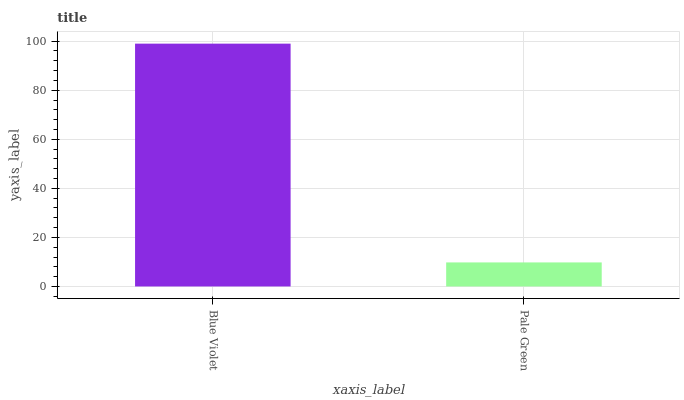Is Pale Green the minimum?
Answer yes or no. Yes. Is Blue Violet the maximum?
Answer yes or no. Yes. Is Pale Green the maximum?
Answer yes or no. No. Is Blue Violet greater than Pale Green?
Answer yes or no. Yes. Is Pale Green less than Blue Violet?
Answer yes or no. Yes. Is Pale Green greater than Blue Violet?
Answer yes or no. No. Is Blue Violet less than Pale Green?
Answer yes or no. No. Is Blue Violet the high median?
Answer yes or no. Yes. Is Pale Green the low median?
Answer yes or no. Yes. Is Pale Green the high median?
Answer yes or no. No. Is Blue Violet the low median?
Answer yes or no. No. 